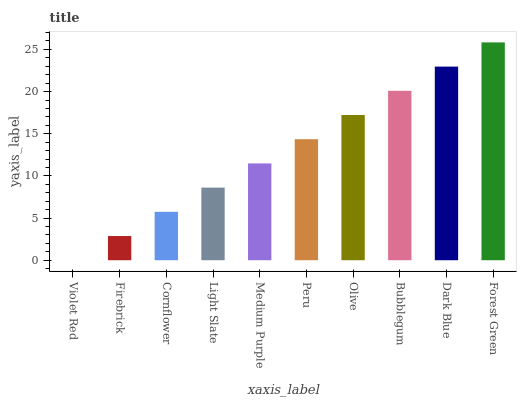Is Violet Red the minimum?
Answer yes or no. Yes. Is Forest Green the maximum?
Answer yes or no. Yes. Is Firebrick the minimum?
Answer yes or no. No. Is Firebrick the maximum?
Answer yes or no. No. Is Firebrick greater than Violet Red?
Answer yes or no. Yes. Is Violet Red less than Firebrick?
Answer yes or no. Yes. Is Violet Red greater than Firebrick?
Answer yes or no. No. Is Firebrick less than Violet Red?
Answer yes or no. No. Is Peru the high median?
Answer yes or no. Yes. Is Medium Purple the low median?
Answer yes or no. Yes. Is Forest Green the high median?
Answer yes or no. No. Is Dark Blue the low median?
Answer yes or no. No. 